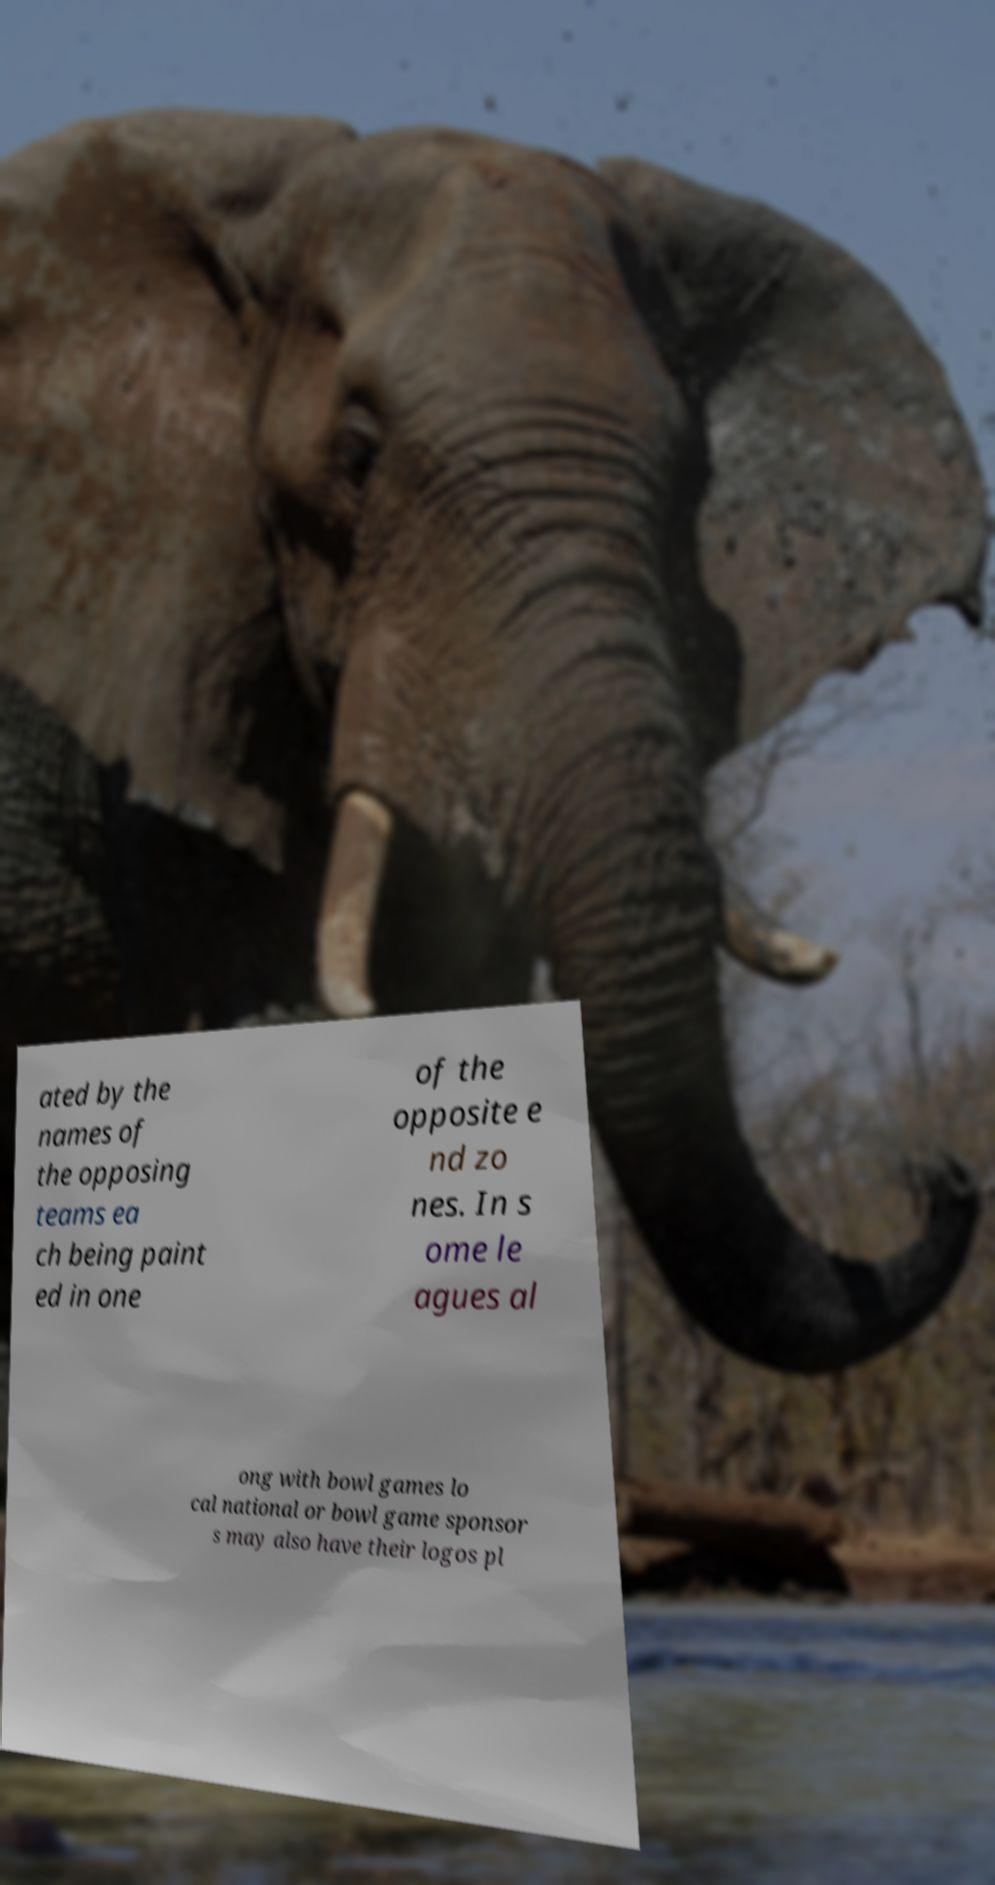There's text embedded in this image that I need extracted. Can you transcribe it verbatim? ated by the names of the opposing teams ea ch being paint ed in one of the opposite e nd zo nes. In s ome le agues al ong with bowl games lo cal national or bowl game sponsor s may also have their logos pl 